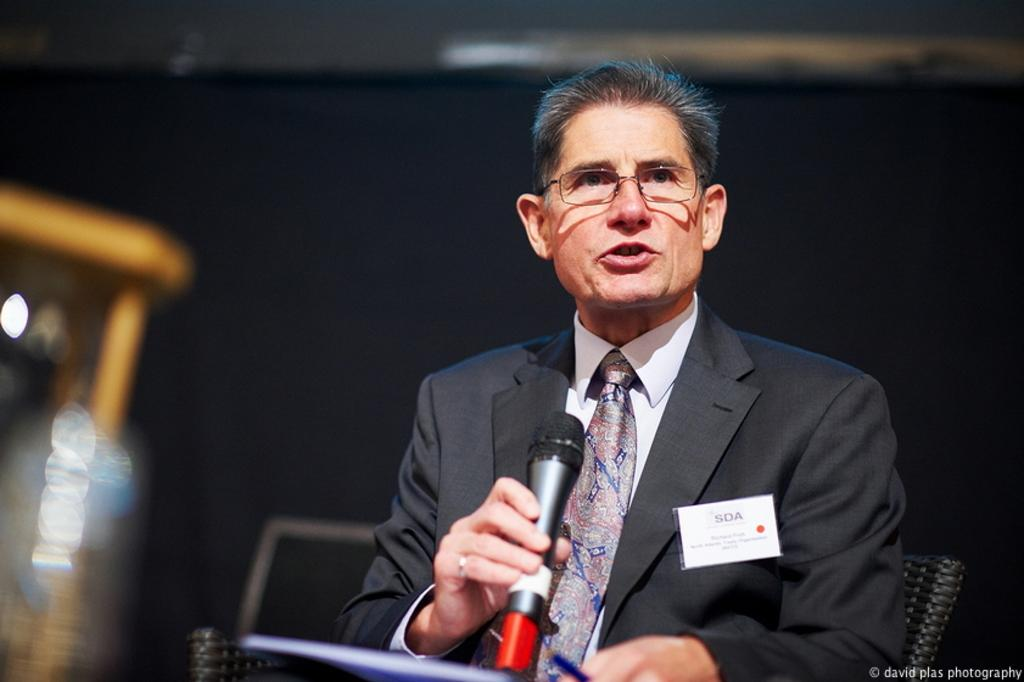What is the main subject of the image? There is a person in the center of the image. What is the person doing in the image? The person is sitting on a chair and holding a microphone in his hand. What might the person be doing with the microphone? The person's mouth is open, suggesting he is speaking into the microphone. Can you see the person's mother in the image? There is no mention of the person's mother in the provided facts, so we cannot determine if she is present in the image. Are there any snakes visible in the image? There is no mention of snakes in the provided facts, so we cannot determine if they are present in the image. 